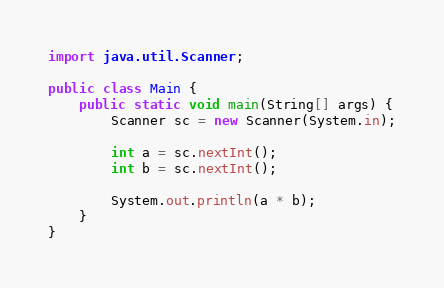<code> <loc_0><loc_0><loc_500><loc_500><_Java_>import java.util.Scanner;
        
public class Main {
    public static void main(String[] args) {
        Scanner sc = new Scanner(System.in);
        
        int a = sc.nextInt();
        int b = sc.nextInt();
        
        System.out.println(a * b);
    }
}</code> 